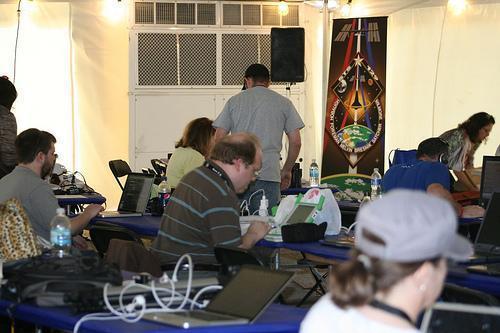How many windows in the room?
Give a very brief answer. 2. How many water bottles are there?
Give a very brief answer. 3. How many laptops are there?
Give a very brief answer. 5. How many people can be seen?
Give a very brief answer. 6. 